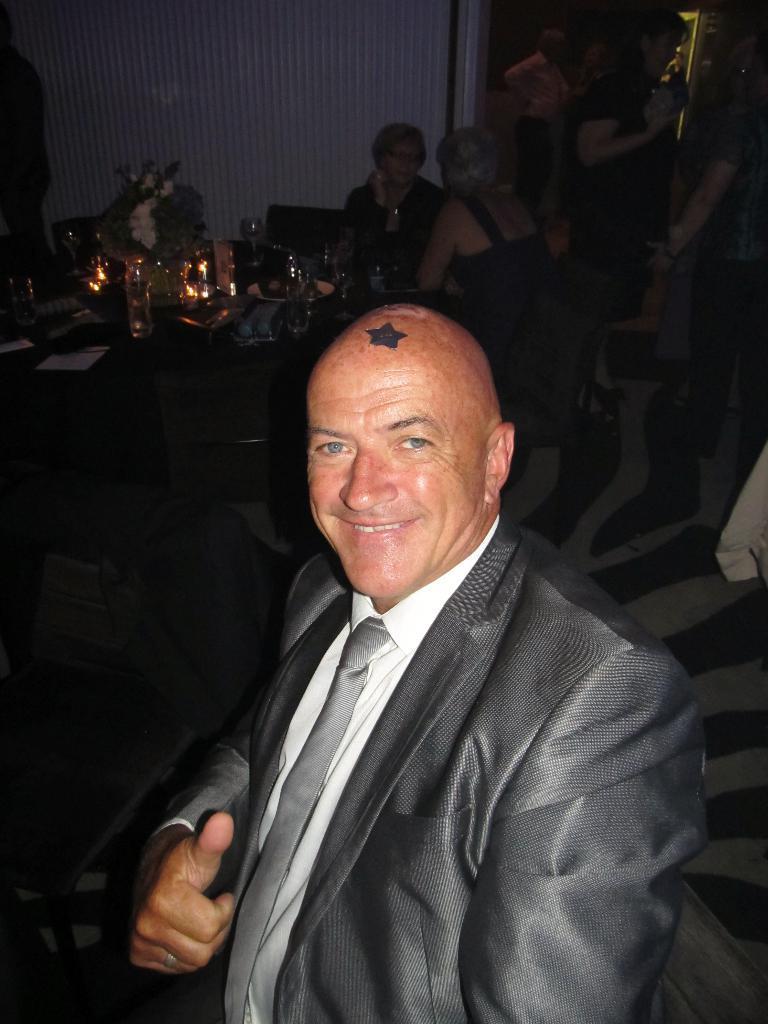Describe this image in one or two sentences. In this picture there is a man sitting and smiling. At the back there are two people sitting on the chairs and there is a table. There are glasses, plates and papers and there is a flower vase on the table and there might be a door. At the bottom there is a floor. 